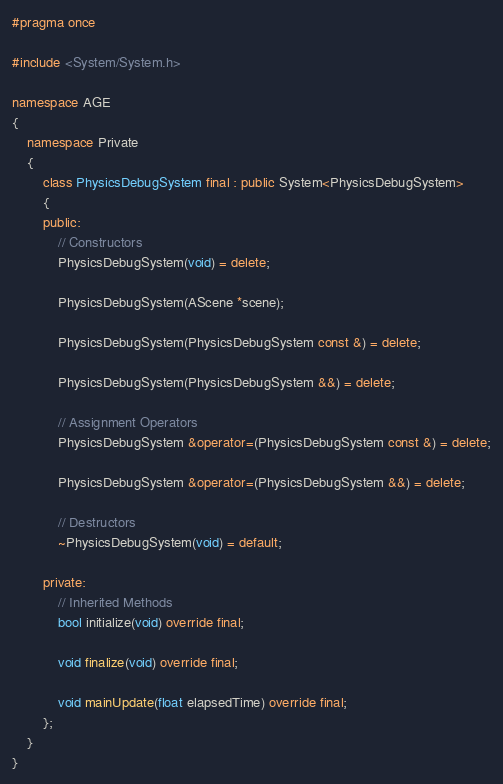<code> <loc_0><loc_0><loc_500><loc_500><_C++_>#pragma once

#include <System/System.h>

namespace AGE
{
	namespace Private
	{
		class PhysicsDebugSystem final : public System<PhysicsDebugSystem>
		{
		public:
			// Constructors
			PhysicsDebugSystem(void) = delete;

			PhysicsDebugSystem(AScene *scene);

			PhysicsDebugSystem(PhysicsDebugSystem const &) = delete;

			PhysicsDebugSystem(PhysicsDebugSystem &&) = delete;

			// Assignment Operators
			PhysicsDebugSystem &operator=(PhysicsDebugSystem const &) = delete;

			PhysicsDebugSystem &operator=(PhysicsDebugSystem &&) = delete;

			// Destructors
			~PhysicsDebugSystem(void) = default;

		private:
			// Inherited Methods
			bool initialize(void) override final;

			void finalize(void) override final;

			void mainUpdate(float elapsedTime) override final;
		};
	}
}</code> 